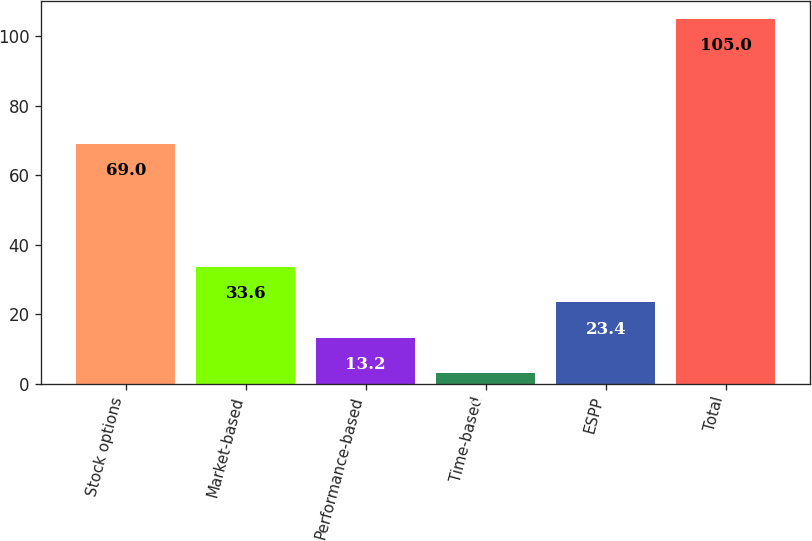Convert chart to OTSL. <chart><loc_0><loc_0><loc_500><loc_500><bar_chart><fcel>Stock options<fcel>Market-based<fcel>Performance-based<fcel>Time-based<fcel>ESPP<fcel>Total<nl><fcel>69<fcel>33.6<fcel>13.2<fcel>3<fcel>23.4<fcel>105<nl></chart> 